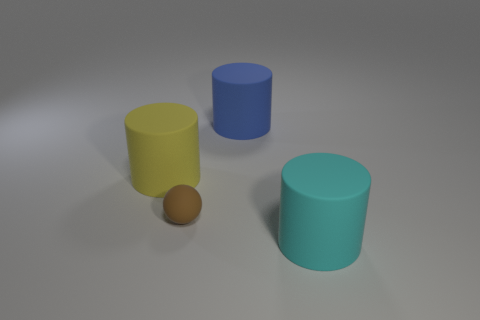Add 3 yellow cylinders. How many objects exist? 7 Subtract all yellow cylinders. How many cylinders are left? 2 Subtract 1 balls. How many balls are left? 0 Subtract all purple spheres. How many cyan cylinders are left? 1 Subtract all small purple matte cubes. Subtract all cylinders. How many objects are left? 1 Add 2 large yellow matte objects. How many large yellow matte objects are left? 3 Add 1 cyan matte things. How many cyan matte things exist? 2 Subtract 0 red cubes. How many objects are left? 4 Subtract all spheres. How many objects are left? 3 Subtract all yellow spheres. Subtract all gray cylinders. How many spheres are left? 1 